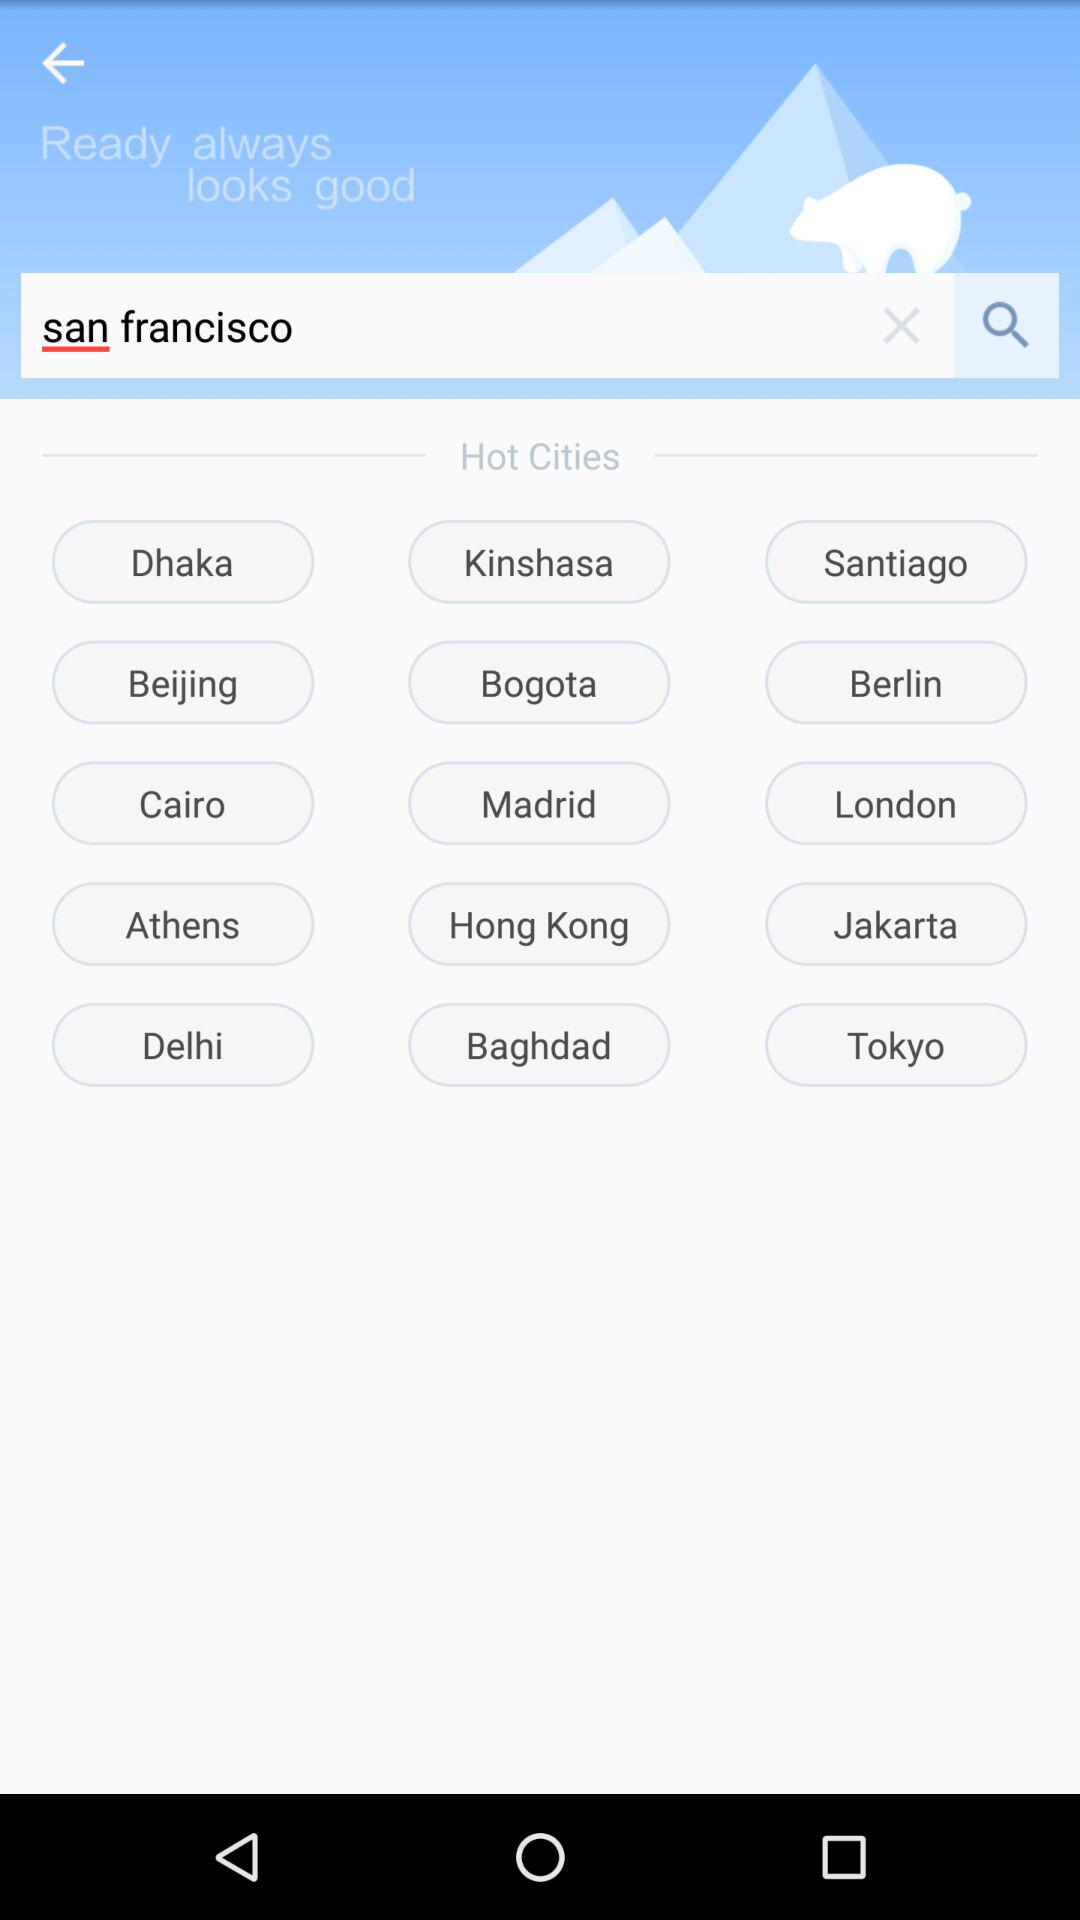How many text inputs are on the screen?
Answer the question using a single word or phrase. 1 